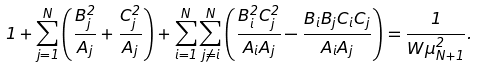<formula> <loc_0><loc_0><loc_500><loc_500>1 + \sum _ { j = 1 } ^ { N } \left ( \frac { B _ { j } ^ { 2 } } { A _ { j } } + \frac { C _ { j } ^ { 2 } } { A _ { j } } \right ) + \sum _ { i = 1 } ^ { N } \sum _ { j \neq i } ^ { N } \left ( \frac { B _ { i } ^ { 2 } C _ { j } ^ { 2 } } { A _ { i } A _ { j } } - \frac { B _ { i } B _ { j } C _ { i } C _ { j } } { A _ { i } A _ { j } } \right ) = \frac { 1 } { W \mu _ { N + 1 } ^ { 2 } } .</formula> 